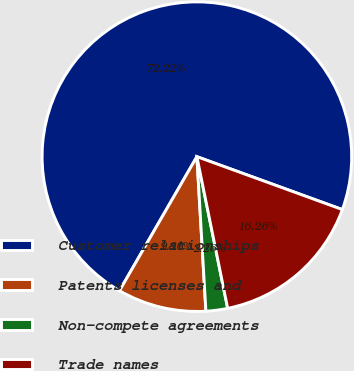Convert chart to OTSL. <chart><loc_0><loc_0><loc_500><loc_500><pie_chart><fcel>Customer relationships<fcel>Patents licenses and<fcel>Non-compete agreements<fcel>Trade names<nl><fcel>72.22%<fcel>9.26%<fcel>2.26%<fcel>16.26%<nl></chart> 